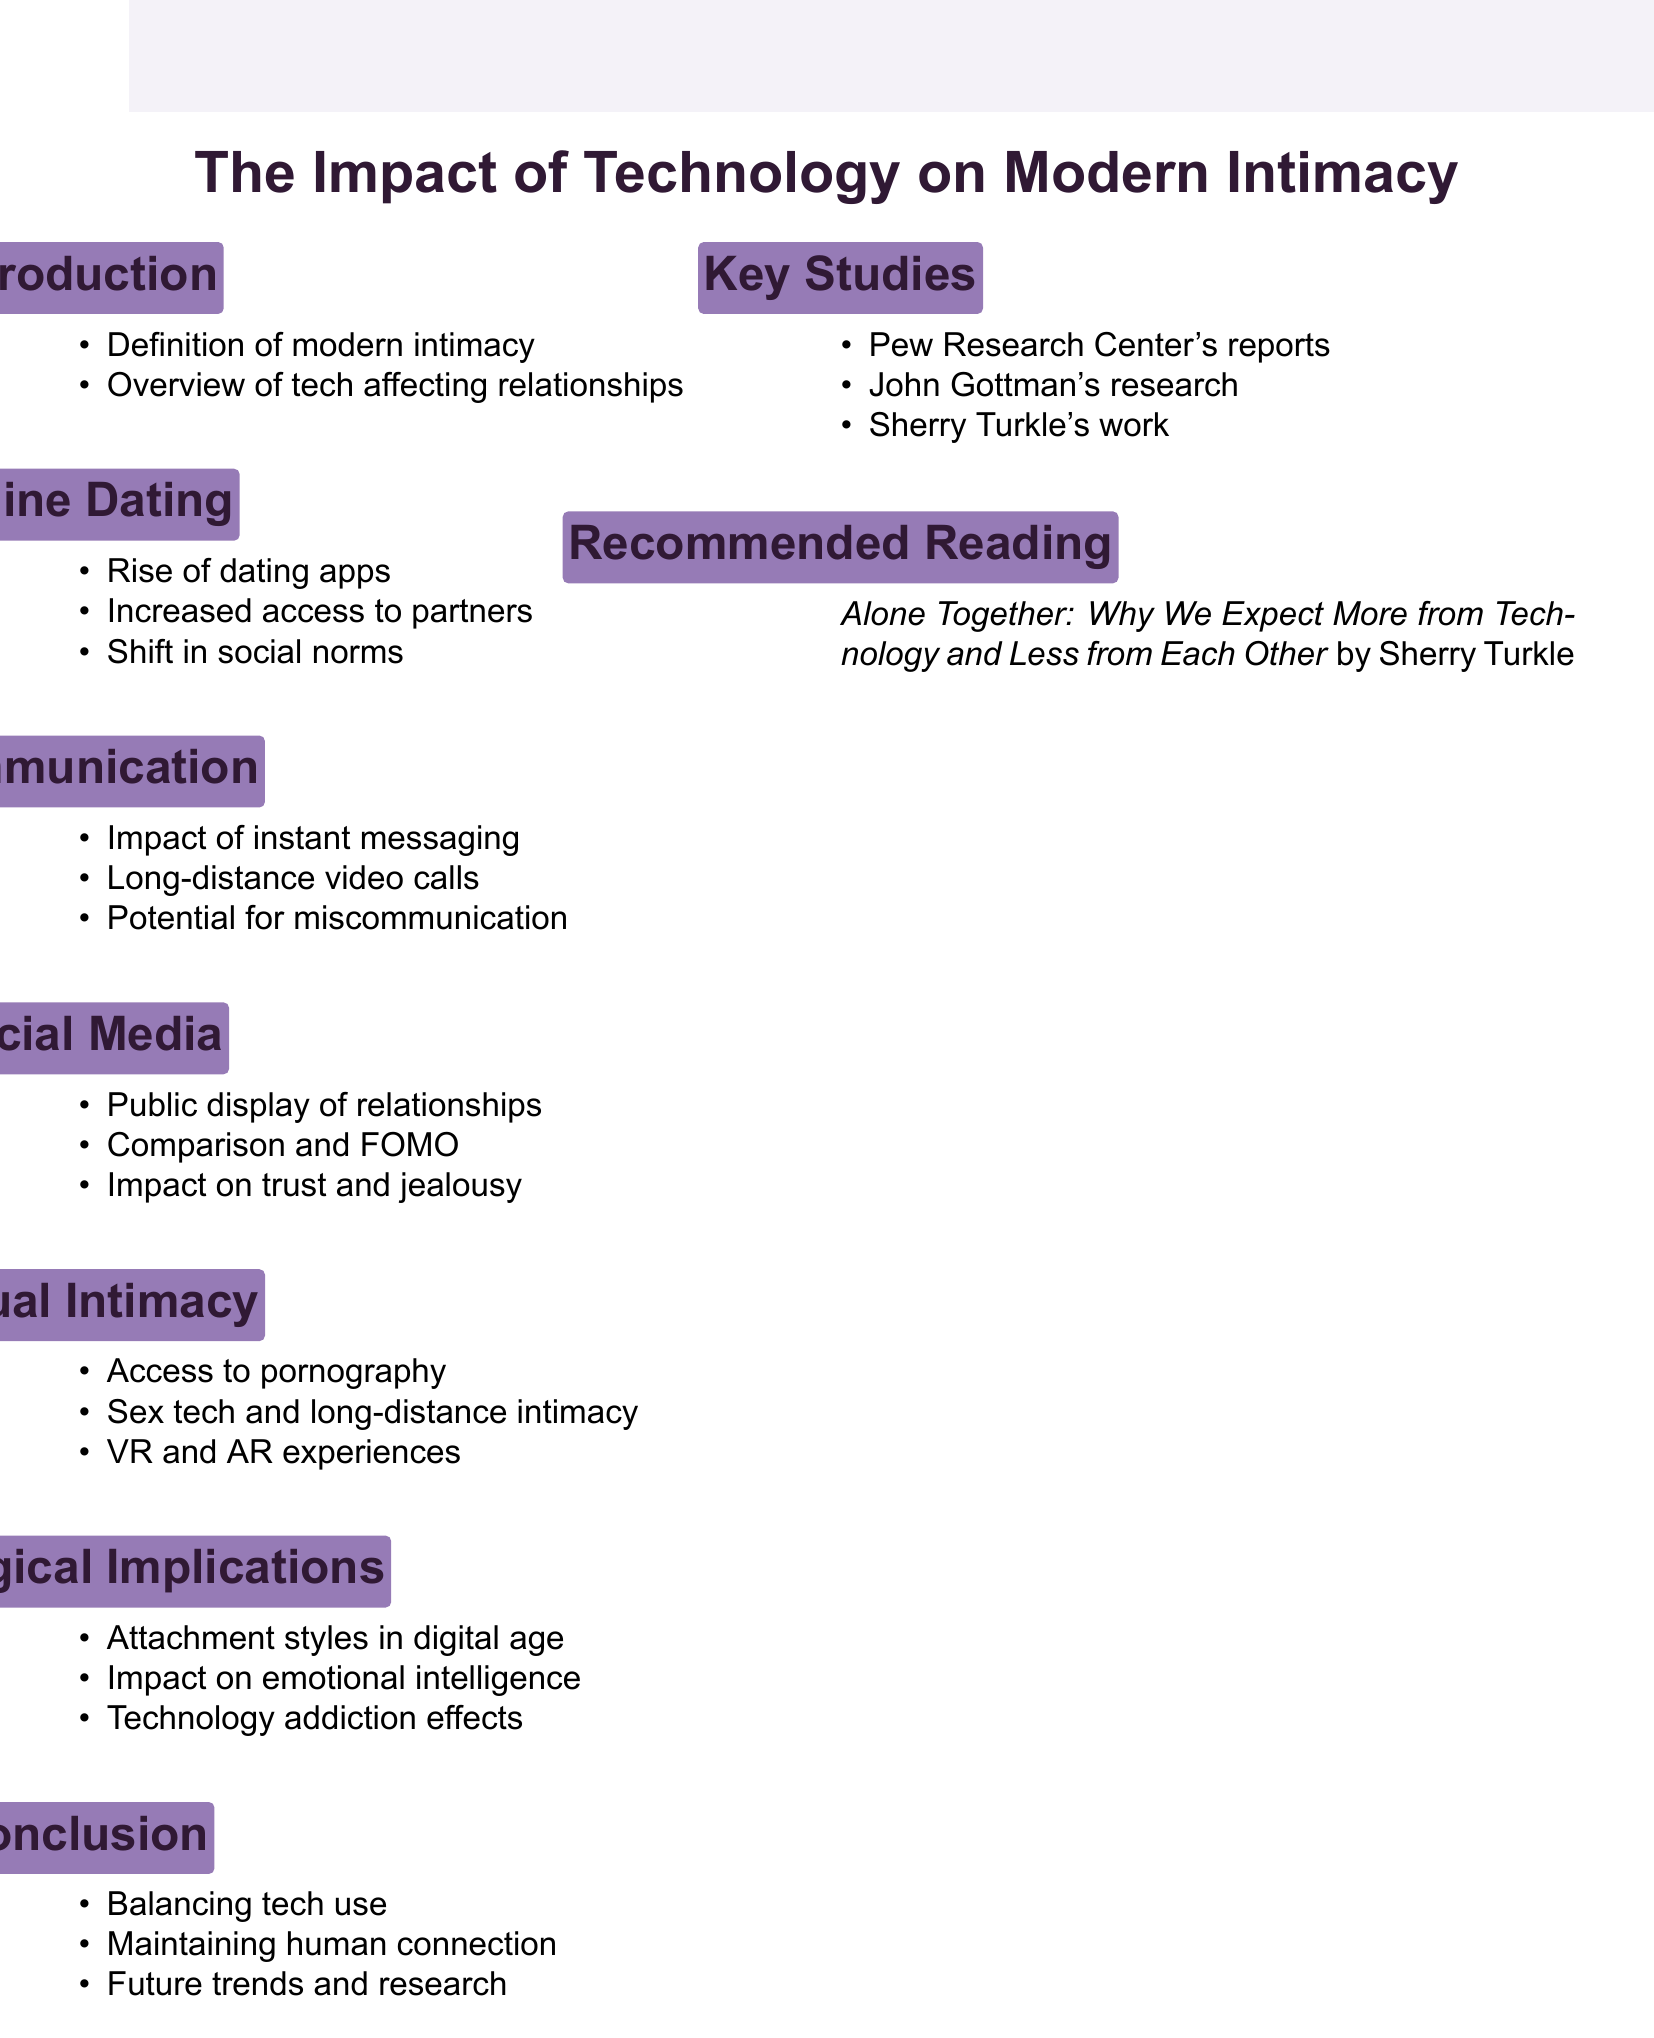What is the title of the lecture? The title is explicitly mentioned at the beginning of the document as "The Impact of Technology on Modern Intimacy".
Answer: The Impact of Technology on Modern Intimacy What is the first point in the Introduction section? The first point under the Introduction section is listed directly as "Definition of modern intimacy".
Answer: Definition of modern intimacy Which section discusses the effects of pornography? The section dedicated to this theme is titled "Technology and Sexual Intimacy", clearly indicating its focus.
Answer: Technology and Sexual Intimacy What does FOMO stand for in the context of the Social Media section? The acronym FOMO is explained as "Fear of Missing Out" within the document, specifically in the Social Media section.
Answer: Fear of Missing Out Which researcher's work is recommended for further reading in the document? The document suggests reading work by Sherry Turkle, who focuses on themes relevant to technology and intimacy.
Answer: Sherry Turkle What impact does technology have on emotional intelligence according to the Psychological Implications section? The document notes the impact on emotional intelligence as a key point in the Psychological Implications section.
Answer: Impact on emotional intelligence How many key studies are mentioned in the document? The document lists three key studies that are referenced.
Answer: Three What type of technology is mentioned in relation to long-distance intimacy? The specific type of technology referred to is "teledildonics" in the section on Technology and Sexual Intimacy.
Answer: Teledildonics What social media platforms are referenced in the context of public display of relationships? The document specifically mentions "Facebook and Instagram" when discussing this aspect.
Answer: Facebook and Instagram 